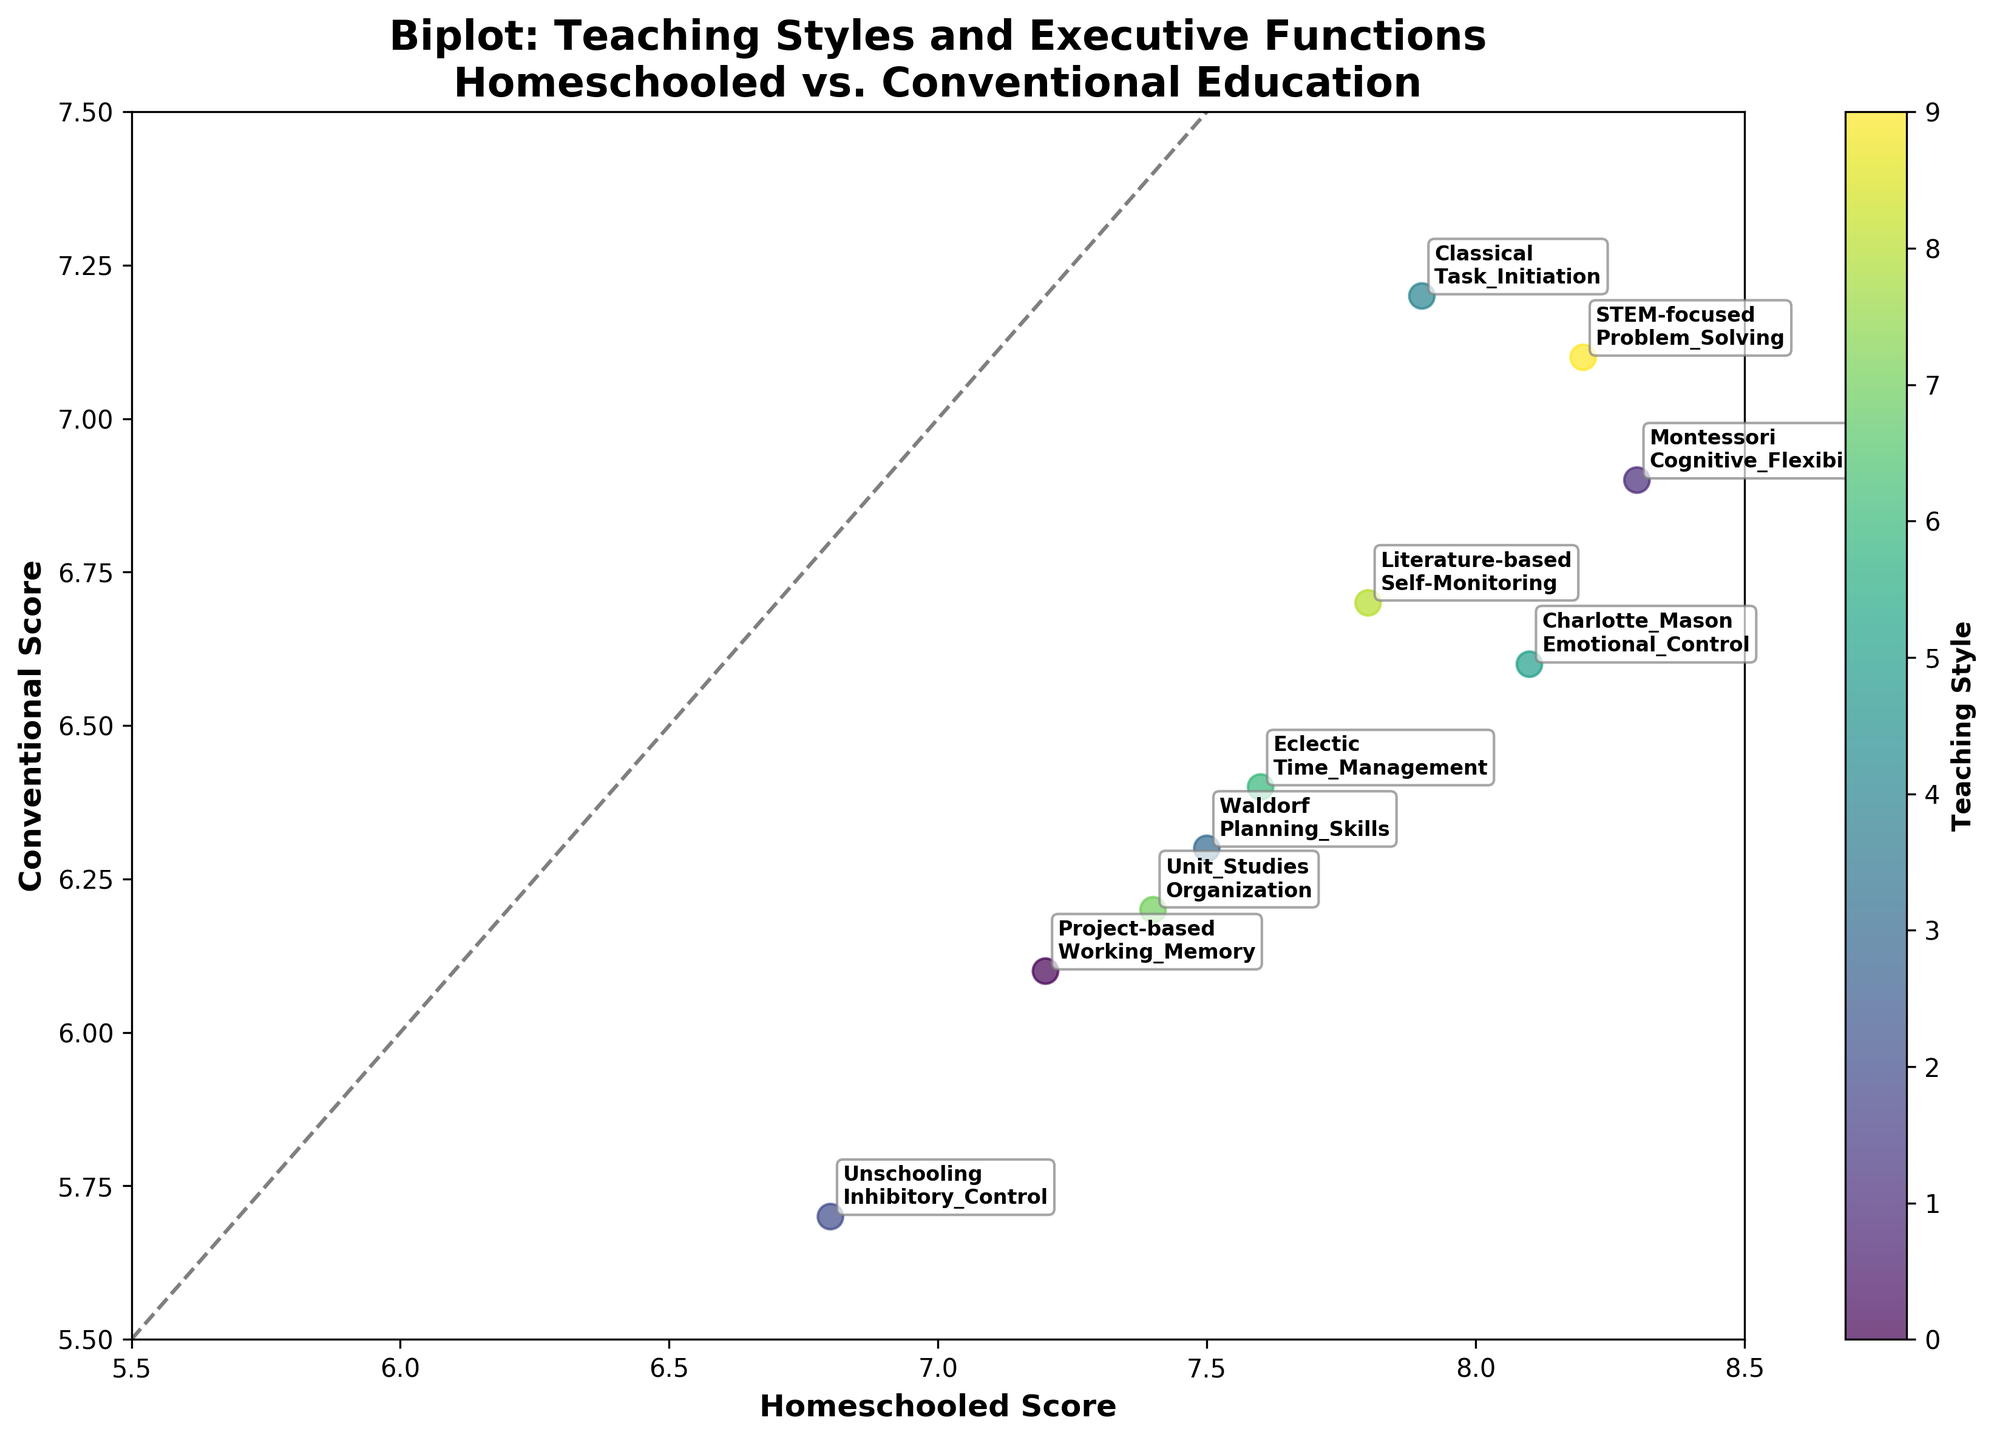What is the title of the figure? The title can be found at the top of the figure and provides a summary of the content displayed. Here, the title says, "Biplot: Teaching Styles and Executive Functions: Homeschooled vs. Conventional Education".
Answer: Biplot: Teaching Styles and Executive Functions: Homeschooled vs. Conventional Education How many teaching styles are displayed in the figure? By counting the distinct labels representing teaching styles, we can see there are 10 different teaching styles mentioned.
Answer: 10 Which executive function has the highest score for homeschooled students? We need to look at the vertical axis labeled "Homeschooled Score" and find the highest value. The highest score is 8.3, associated with "Montessori" style and "Cognitive Flexibility" function.
Answer: Cognitive Flexibility Which data point is closest to the diagonal line, indicating similar scores in both teaching methods? By visually inspecting the data points in comparison to the diagonal line (where the scores for both teaching methods are equal), the point for "Classical" teaching style and "Task Initiation" function appears closest.
Answer: Task Initiation What teaching style is associated with the lowest executive function score for conventionally educated students? By examining the horizontal axis for the lowest score, we find the score of 5.7, which corresponds to "Unschooling" style and "Inhibitory Control" function.
Answer: Inhibitory Control Which teaching style shows a stronger benefit in homeschooled scores compared to conventional scores based on biplot distances? We need to look for the largest vertical distance from the diagonal line where the homeschooled score significantly higher compared to conventional; "Montessori" style and "Cognitive Flexibility" function show the largest difference.
Answer: Montessori On average, do homeschooled students perform better in executive functions than conventionally educated students? Visually averaging the placement of all points above or below the diagonal line helps; more points are positioned higher above the diagonal line, indicating better performance for homeschooled students on average.
Answer: Yes What teaching style associated with "Planning Skills" is used, and how do its scores compare between homeschooled and conventional education? The point labeled "Planning Skills" correlates with the "Waldorf" teaching style, with a homeschooled score of 7.5 and a conventional score of 6.3, indicating higher performance for homeschooled students.
Answer: Waldorf; Homeschooled higher Which teaching styles show the smallest difference in scores between homeschooled and conventional students? By identifying the points closest to the diagonal, "Classical" and "STEM-focused" styles show minimal differences between the scores.
Answer: Classical, STEM-focused 